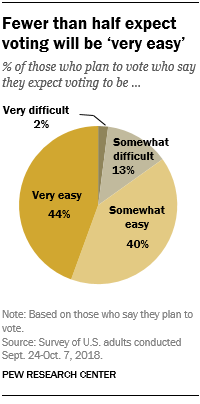Indicate a few pertinent items in this graphic. The "Pie chart" represents the biggest piece of the pie, making it an easy answer to the question. The pie chart is divided into four parts. 